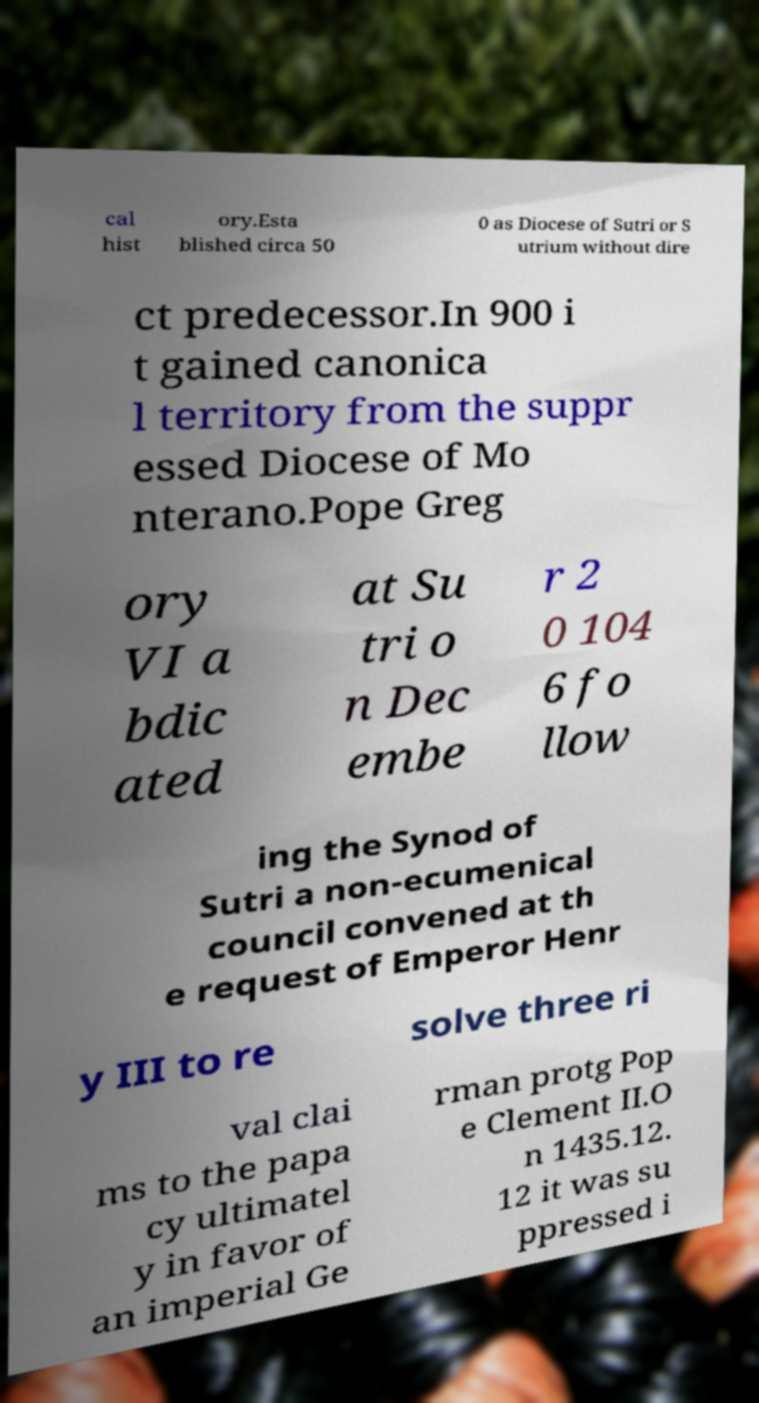Could you extract and type out the text from this image? cal hist ory.Esta blished circa 50 0 as Diocese of Sutri or S utrium without dire ct predecessor.In 900 i t gained canonica l territory from the suppr essed Diocese of Mo nterano.Pope Greg ory VI a bdic ated at Su tri o n Dec embe r 2 0 104 6 fo llow ing the Synod of Sutri a non-ecumenical council convened at th e request of Emperor Henr y III to re solve three ri val clai ms to the papa cy ultimatel y in favor of an imperial Ge rman protg Pop e Clement II.O n 1435.12. 12 it was su ppressed i 